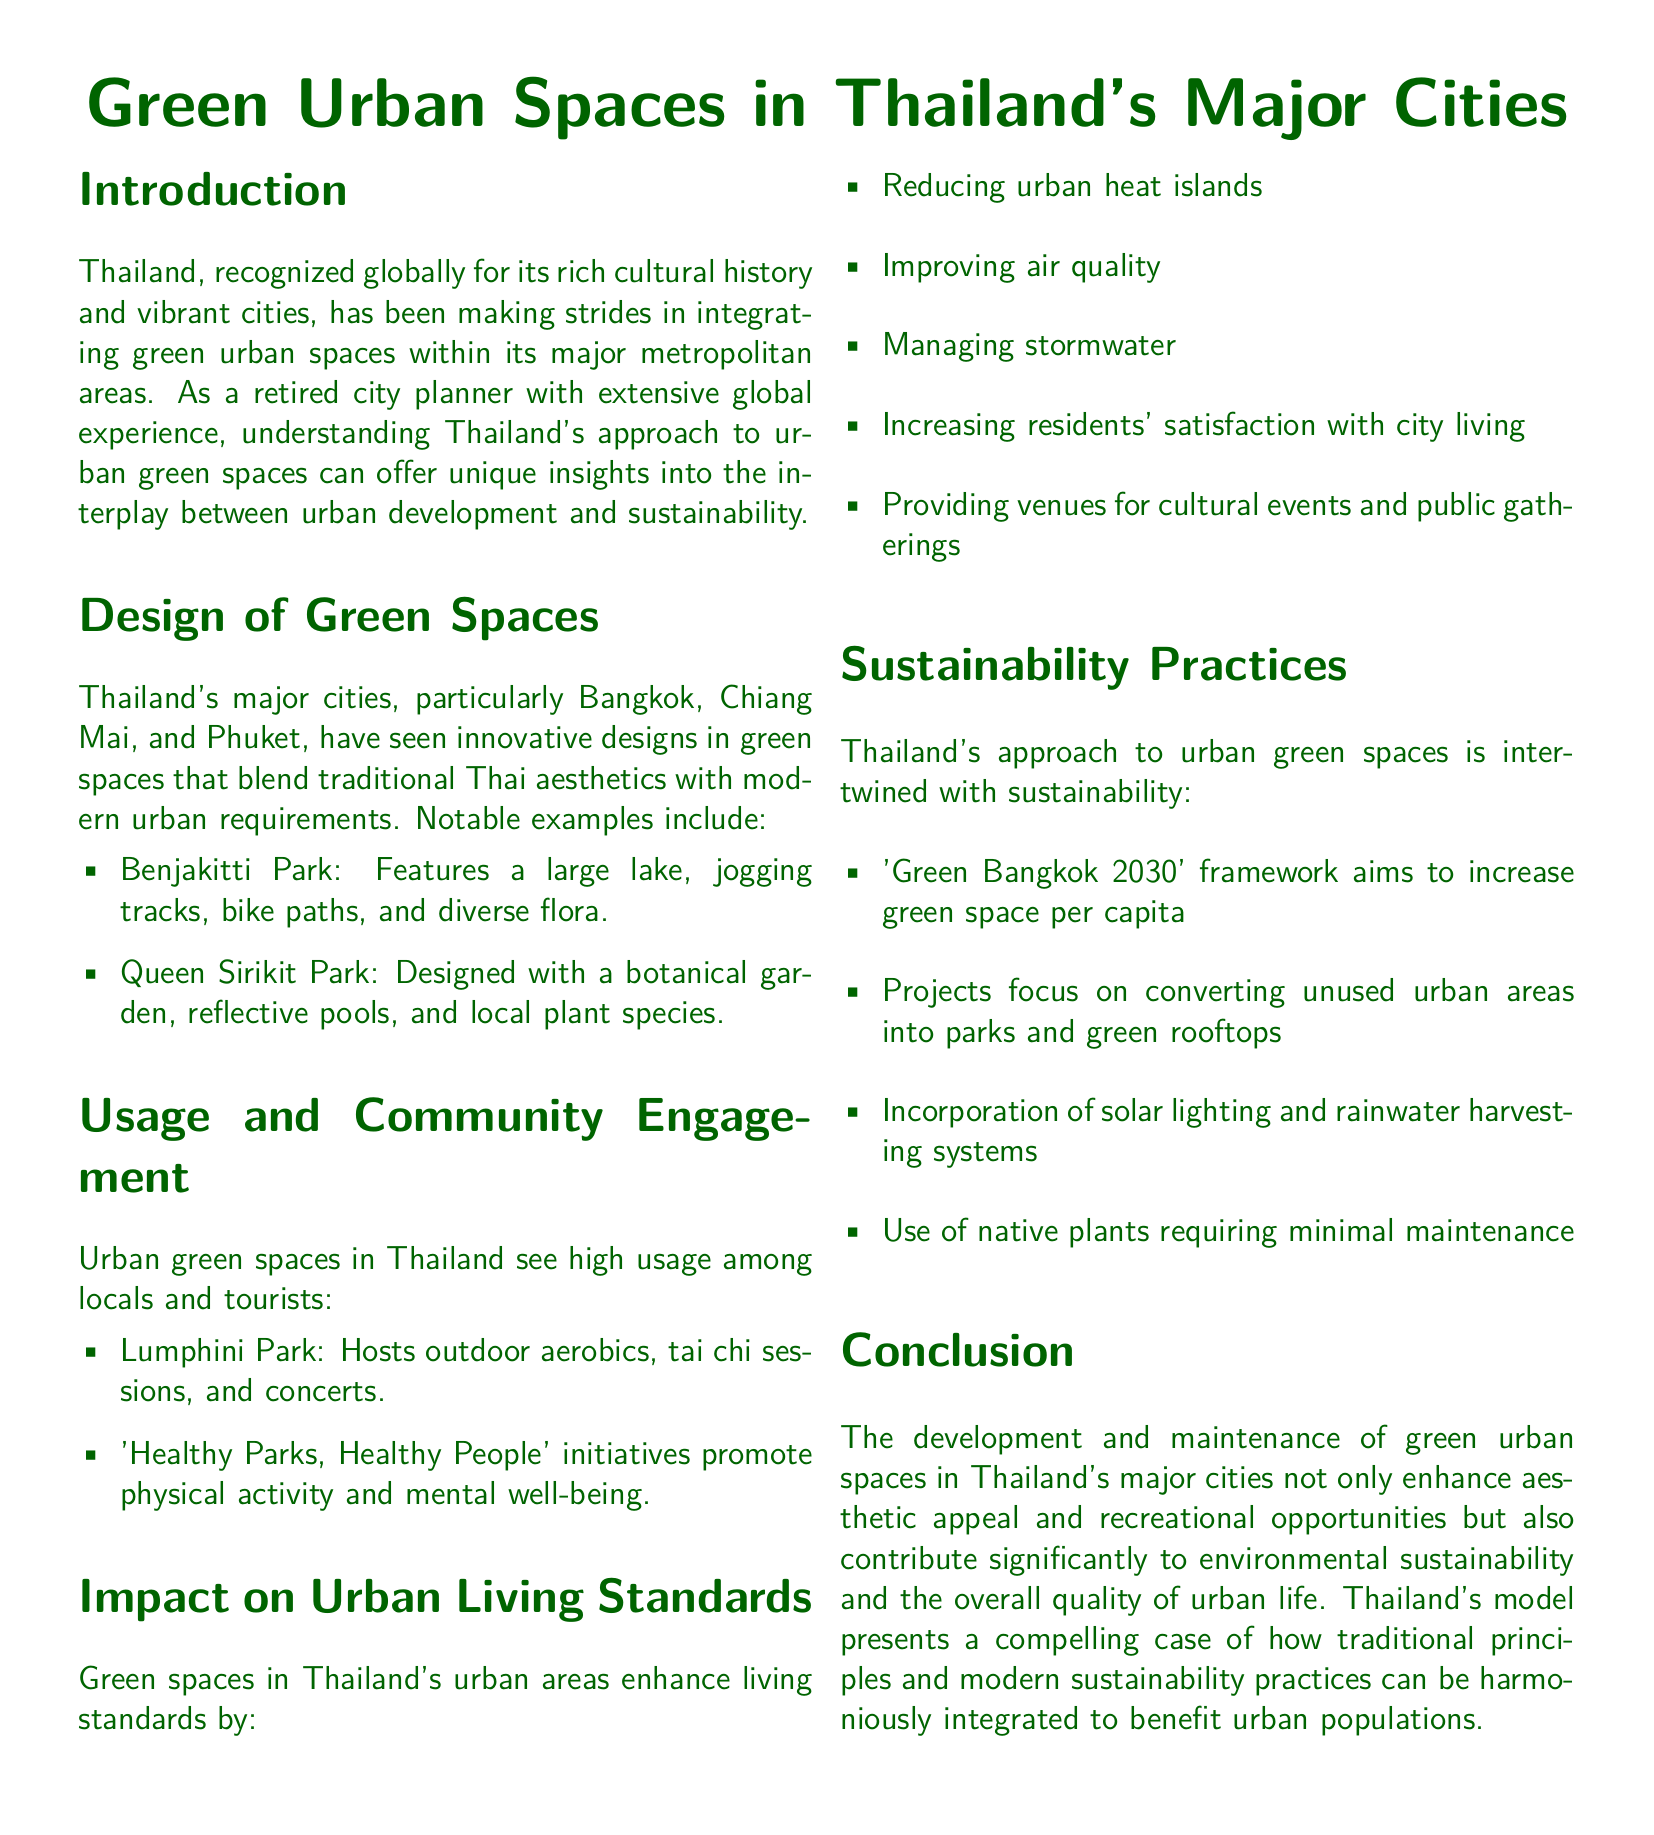what is the focus of the document? The document focuses on a comprehensive review of green spaces and parks in urban areas of Thailand, highlighting their design, usage, and impact.
Answer: green spaces and parks which city is mentioned as having Benjakitti Park? The document specifically mentions Bangkok as having Benjakitti Park.
Answer: Bangkok what initiative promotes physical activity in urban parks? The document refers to the 'Healthy Parks, Healthy People' initiative, which promotes physical activity and mental well-being.
Answer: Healthy Parks, Healthy People how does the 'Green Bangkok 2030' framework aim to improve urban areas? The framework aims to increase green space per capita in Thailand's urban areas.
Answer: increase green space per capita which park features a botanical garden? Queen Sirikit Park is noted for its design that includes a botanical garden.
Answer: Queen Sirikit Park what is one impact of green spaces on urban living standards? The document states that green spaces improve air quality as one of their impacts.
Answer: improving air quality name one sustainability practice mentioned in the document. The document mentions the incorporation of solar lighting as a sustainability practice in urban spaces.
Answer: solar lighting how many major cities in Thailand are specifically focused on in the document? The document highlights three major cities in Thailand specifically: Bangkok, Chiang Mai, and Phuket.
Answer: three what does the document suggest about the relationship between traditional principles and modern sustainability practices? The document suggests that they can be harmoniously integrated to benefit urban populations.
Answer: harmoniously integrated 